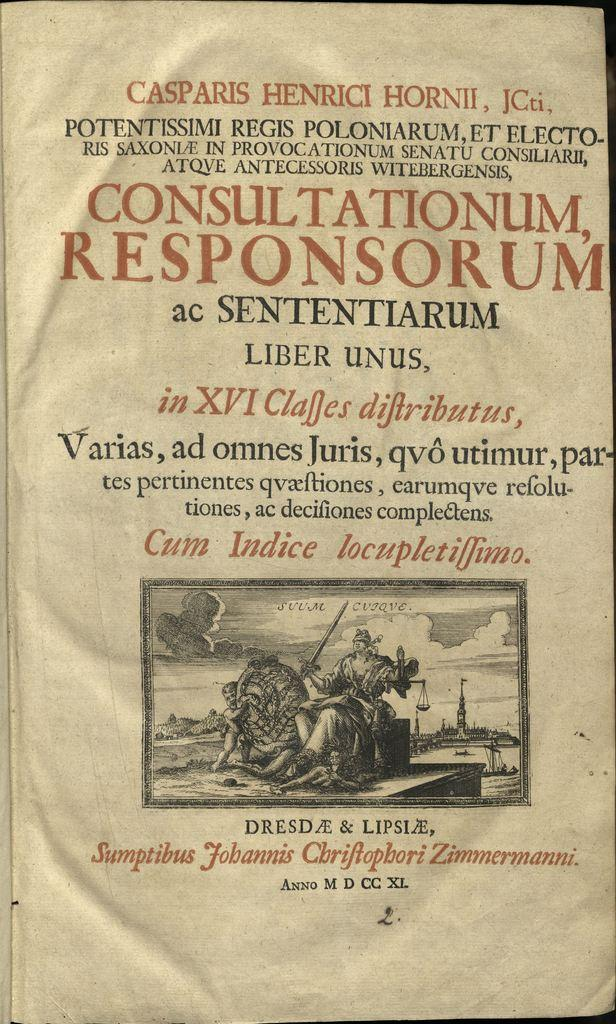<image>
Provide a brief description of the given image. An old book titled Consultationum, Responsorum ac Sententiarum. 